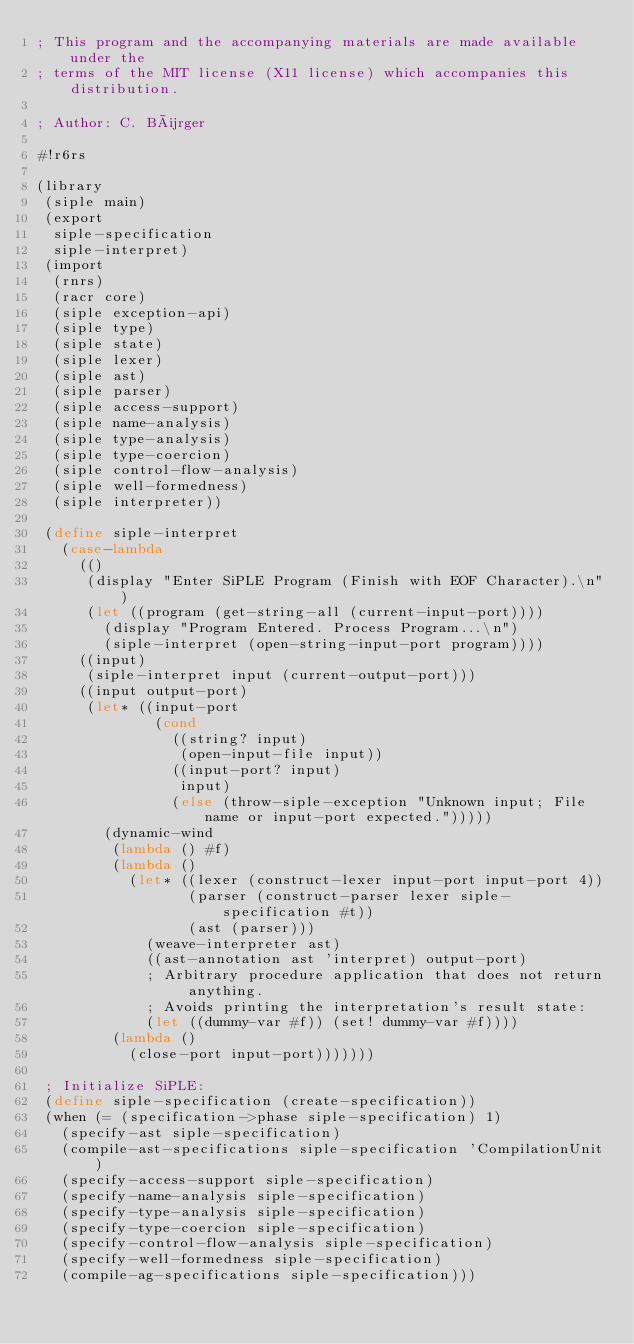Convert code to text. <code><loc_0><loc_0><loc_500><loc_500><_Scheme_>; This program and the accompanying materials are made available under the
; terms of the MIT license (X11 license) which accompanies this distribution.

; Author: C. Bürger

#!r6rs

(library
 (siple main)
 (export
  siple-specification
  siple-interpret)
 (import
  (rnrs)
  (racr core)
  (siple exception-api)
  (siple type)
  (siple state)
  (siple lexer)
  (siple ast)
  (siple parser)
  (siple access-support)
  (siple name-analysis)
  (siple type-analysis)
  (siple type-coercion)
  (siple control-flow-analysis)
  (siple well-formedness)
  (siple interpreter))
 
 (define siple-interpret
   (case-lambda
     (()
      (display "Enter SiPLE Program (Finish with EOF Character).\n")
      (let ((program (get-string-all (current-input-port))))
        (display "Program Entered. Process Program...\n")
        (siple-interpret (open-string-input-port program))))
     ((input)
      (siple-interpret input (current-output-port)))
     ((input output-port)
      (let* ((input-port
              (cond
                ((string? input)
                 (open-input-file input))
                ((input-port? input)
                 input)
                (else (throw-siple-exception "Unknown input; File name or input-port expected.")))))
        (dynamic-wind
         (lambda () #f)
         (lambda ()
           (let* ((lexer (construct-lexer input-port input-port 4))
                  (parser (construct-parser lexer siple-specification #t))
                  (ast (parser)))
             (weave-interpreter ast)
             ((ast-annotation ast 'interpret) output-port)
             ; Arbitrary procedure application that does not return anything.
             ; Avoids printing the interpretation's result state:
             (let ((dummy-var #f)) (set! dummy-var #f))))
         (lambda ()
           (close-port input-port)))))))
 
 ; Initialize SiPLE:
 (define siple-specification (create-specification))
 (when (= (specification->phase siple-specification) 1)
   (specify-ast siple-specification)
   (compile-ast-specifications siple-specification 'CompilationUnit)
   (specify-access-support siple-specification)
   (specify-name-analysis siple-specification)
   (specify-type-analysis siple-specification)
   (specify-type-coercion siple-specification)
   (specify-control-flow-analysis siple-specification)
   (specify-well-formedness siple-specification)
   (compile-ag-specifications siple-specification)))</code> 